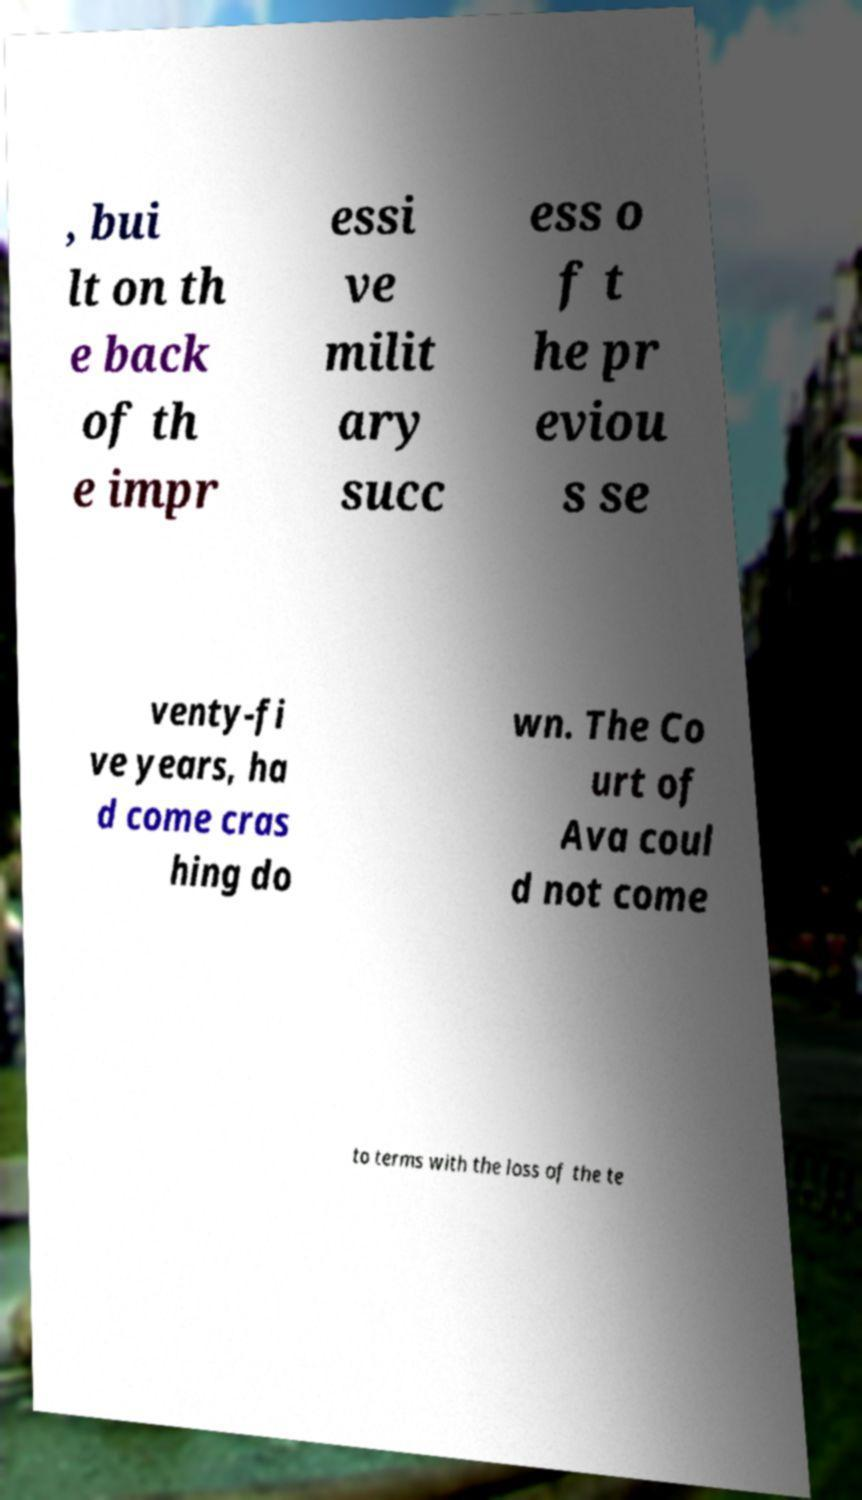There's text embedded in this image that I need extracted. Can you transcribe it verbatim? , bui lt on th e back of th e impr essi ve milit ary succ ess o f t he pr eviou s se venty-fi ve years, ha d come cras hing do wn. The Co urt of Ava coul d not come to terms with the loss of the te 